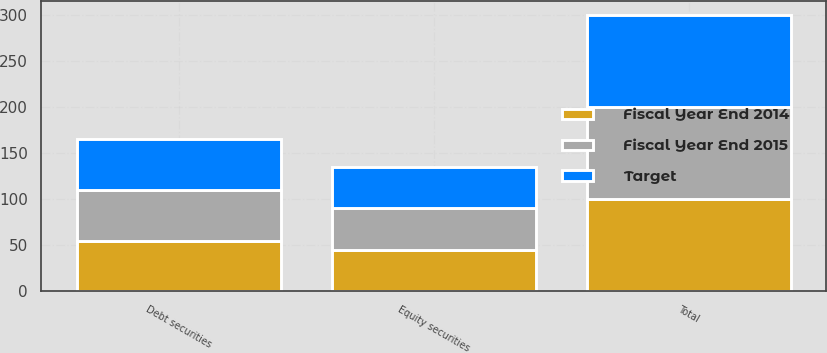Convert chart. <chart><loc_0><loc_0><loc_500><loc_500><stacked_bar_chart><ecel><fcel>Equity securities<fcel>Debt securities<fcel>Total<nl><fcel>Fiscal Year End 2014<fcel>45<fcel>55<fcel>100<nl><fcel>Fiscal Year End 2015<fcel>45<fcel>55<fcel>100<nl><fcel>Target<fcel>45<fcel>55<fcel>100<nl></chart> 